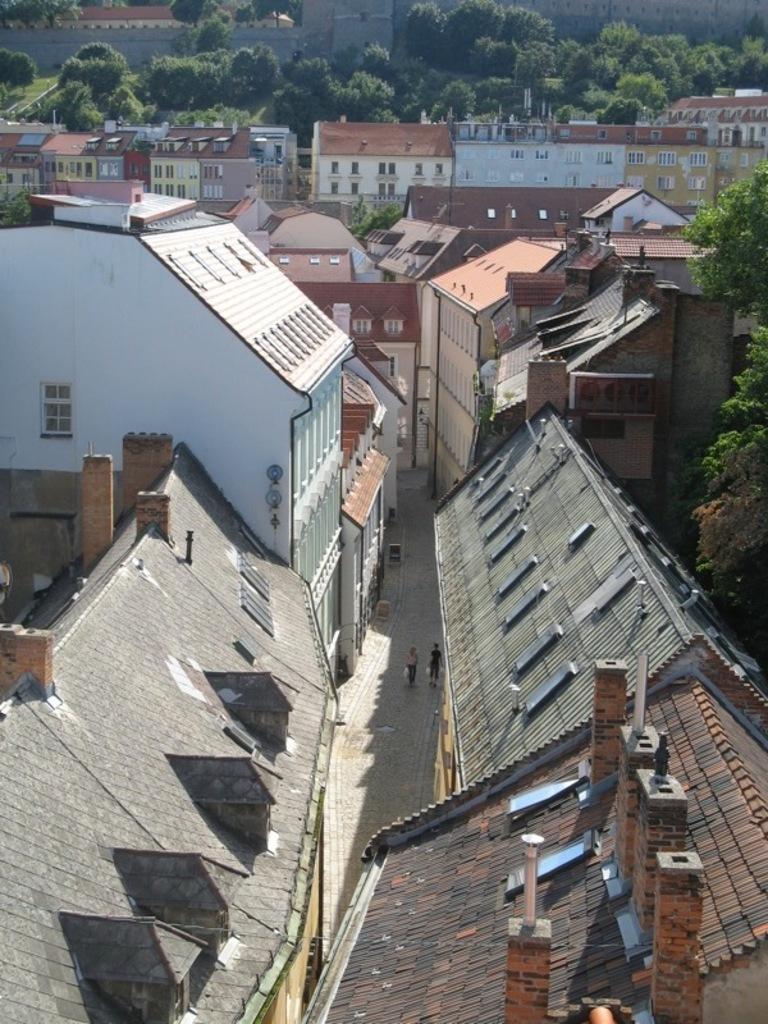In one or two sentences, can you explain what this image depicts? In this image I can see few buildings and I can also two persons walking. In the background I can see few trees in green color. 